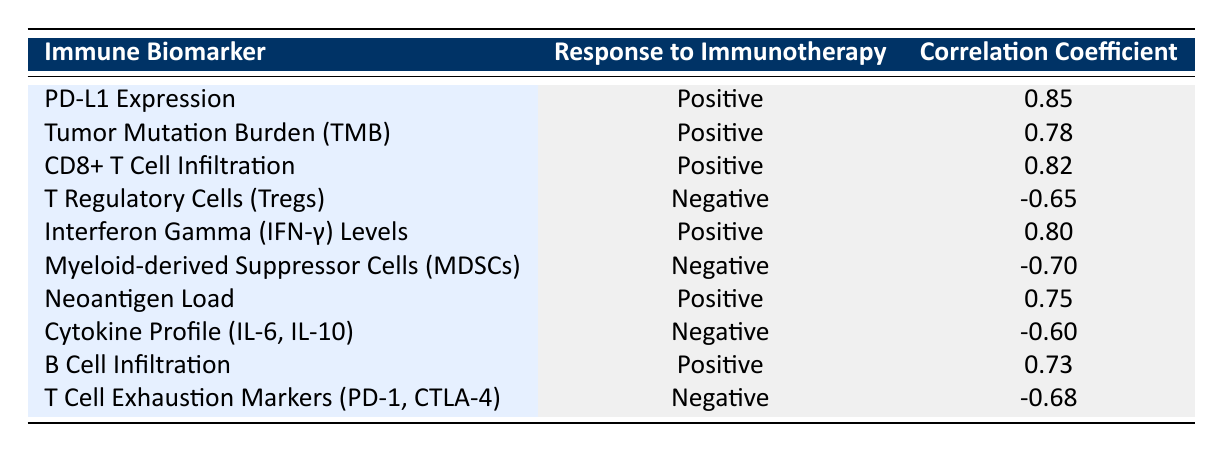What is the correlation coefficient for PD-L1 Expression? The table lists the correlation value for PD-L1 Expression under the "Correlation Coefficient" column, which is 0.85.
Answer: 0.85 How many immune biomarkers have a positive correlation with response to immunotherapy? By counting the rows where the "Response to Immunotherapy" is "Positive," I find that there are 6 such biomarkers: PD-L1 Expression, Tumor Mutation Burden (TMB), CD8+ T Cell Infiltration, Interferon Gamma (IFN-γ) Levels, Neoantigen Load, and B Cell Infiltration.
Answer: 6 Is the correlation between Cytokine Profile (IL-6, IL-10) and response to immunotherapy positive? The table indicates that the correlation coefficient for Cytokine Profile (IL-6, IL-10) is -0.60, which means it is negative, so the answer is no.
Answer: No Which immune biomarker has the lowest correlation coefficient? The lowest correlation coefficient appears to be -0.70 for Myeloid-derived Suppressor Cells (MDSCs), as observed in the "Correlation Coefficient" column.
Answer: -0.70 If we average the correlation coefficients of the positive biomarkers, what is the result? The positive biomarkers' correlation coefficients are 0.85, 0.78, 0.82, 0.80, 0.75, and 0.73. Adding them gives a total of 4.73, and dividing by 6 (the number of positive biomarkers) results in an average of 0.78833, which can be rounded to 0.79.
Answer: 0.79 How does the correlation coefficient for T Regulatory Cells (Tregs) compare to that of CD8+ T Cell Infiltration? The correlation for T Regulatory Cells (Tregs) is -0.65, while CD8+ T Cell Infiltration has a correlation of 0.82. Since -0.65 is lower than 0.82, T Regulatory Cells have a weaker (negative) correlation compared to CD8+ T Cell Infiltration.
Answer: Weaker Is the correlation coefficient for T Cell Exhaustion Markers (PD-1, CTLA-4) greater than that of Myeloid-derived Suppressor Cells (MDSCs)? The correlation coefficient for T Cell Exhaustion Markers (PD-1, CTLA-4) is -0.68 while for MDSCs, it is -0.70. Since -0.68 is greater than -0.70, the statement is true.
Answer: Yes What is the difference in correlation coefficients between Neoantigen Load and Tumor Mutation Burden (TMB)? The correlation coefficient for Neoantigen Load is 0.75 and for Tumor Mutation Burden (TMB) is 0.78. Subtracting these gives 0.78 - 0.75 = 0.03, indicating a small difference favoring TMB.
Answer: 0.03 Which immune biomarker shows the strongest positive correlation with response to immunotherapy? PD-L1 Expression has the highest correlation coefficient at 0.85, which is greater than any other biomarker listed with a positive correlation.
Answer: PD-L1 Expression 